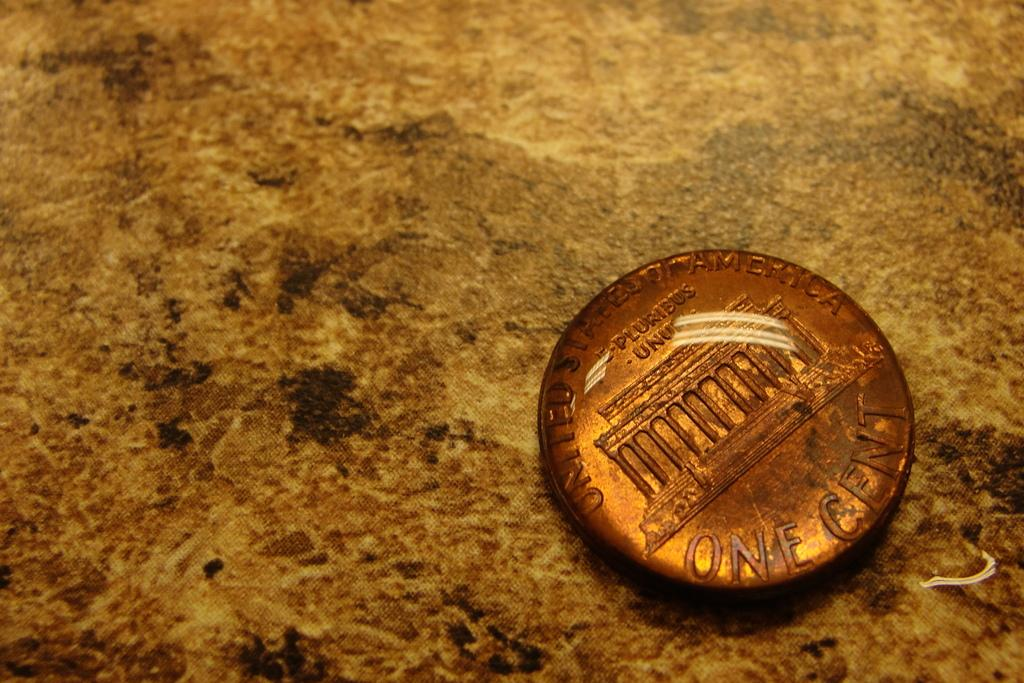<image>
Provide a brief description of the given image. One Cent is etched onto the backside of this coin. 